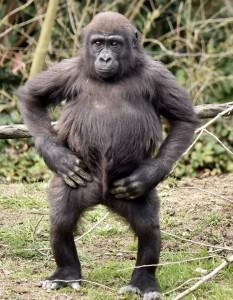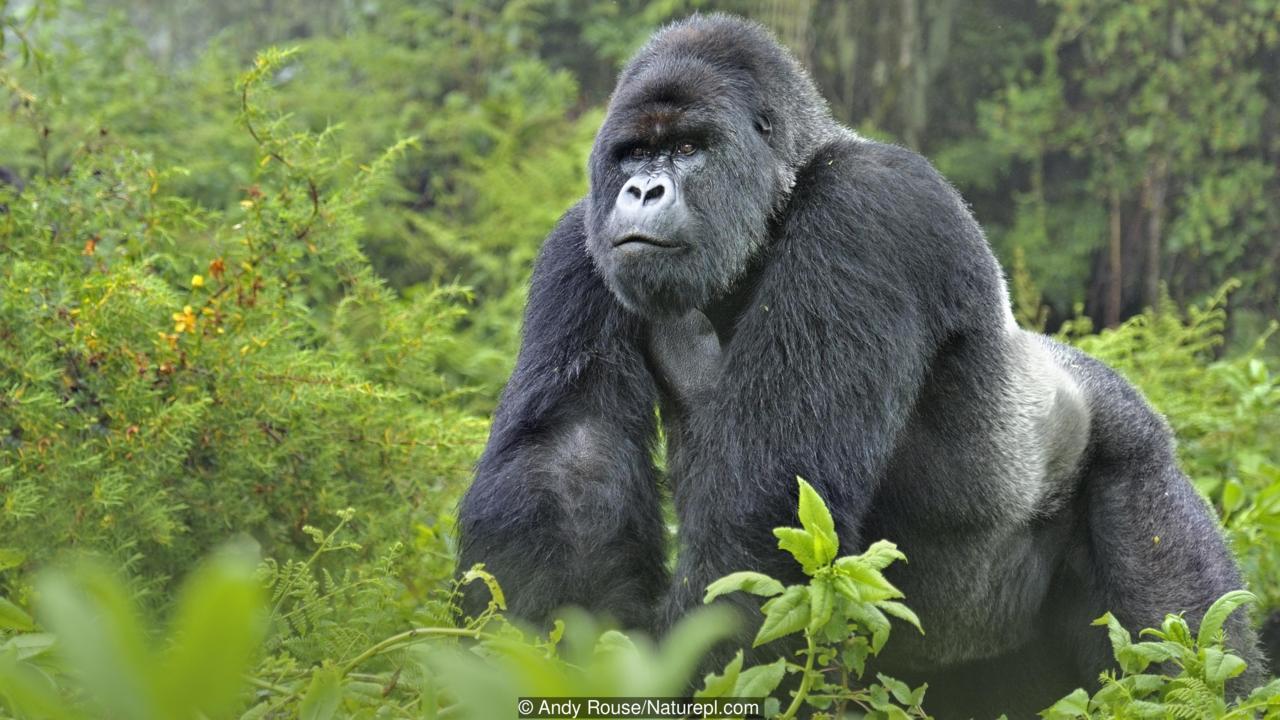The first image is the image on the left, the second image is the image on the right. Evaluate the accuracy of this statement regarding the images: "A baby gorilla is with at least one adult in one image.". Is it true? Answer yes or no. No. 